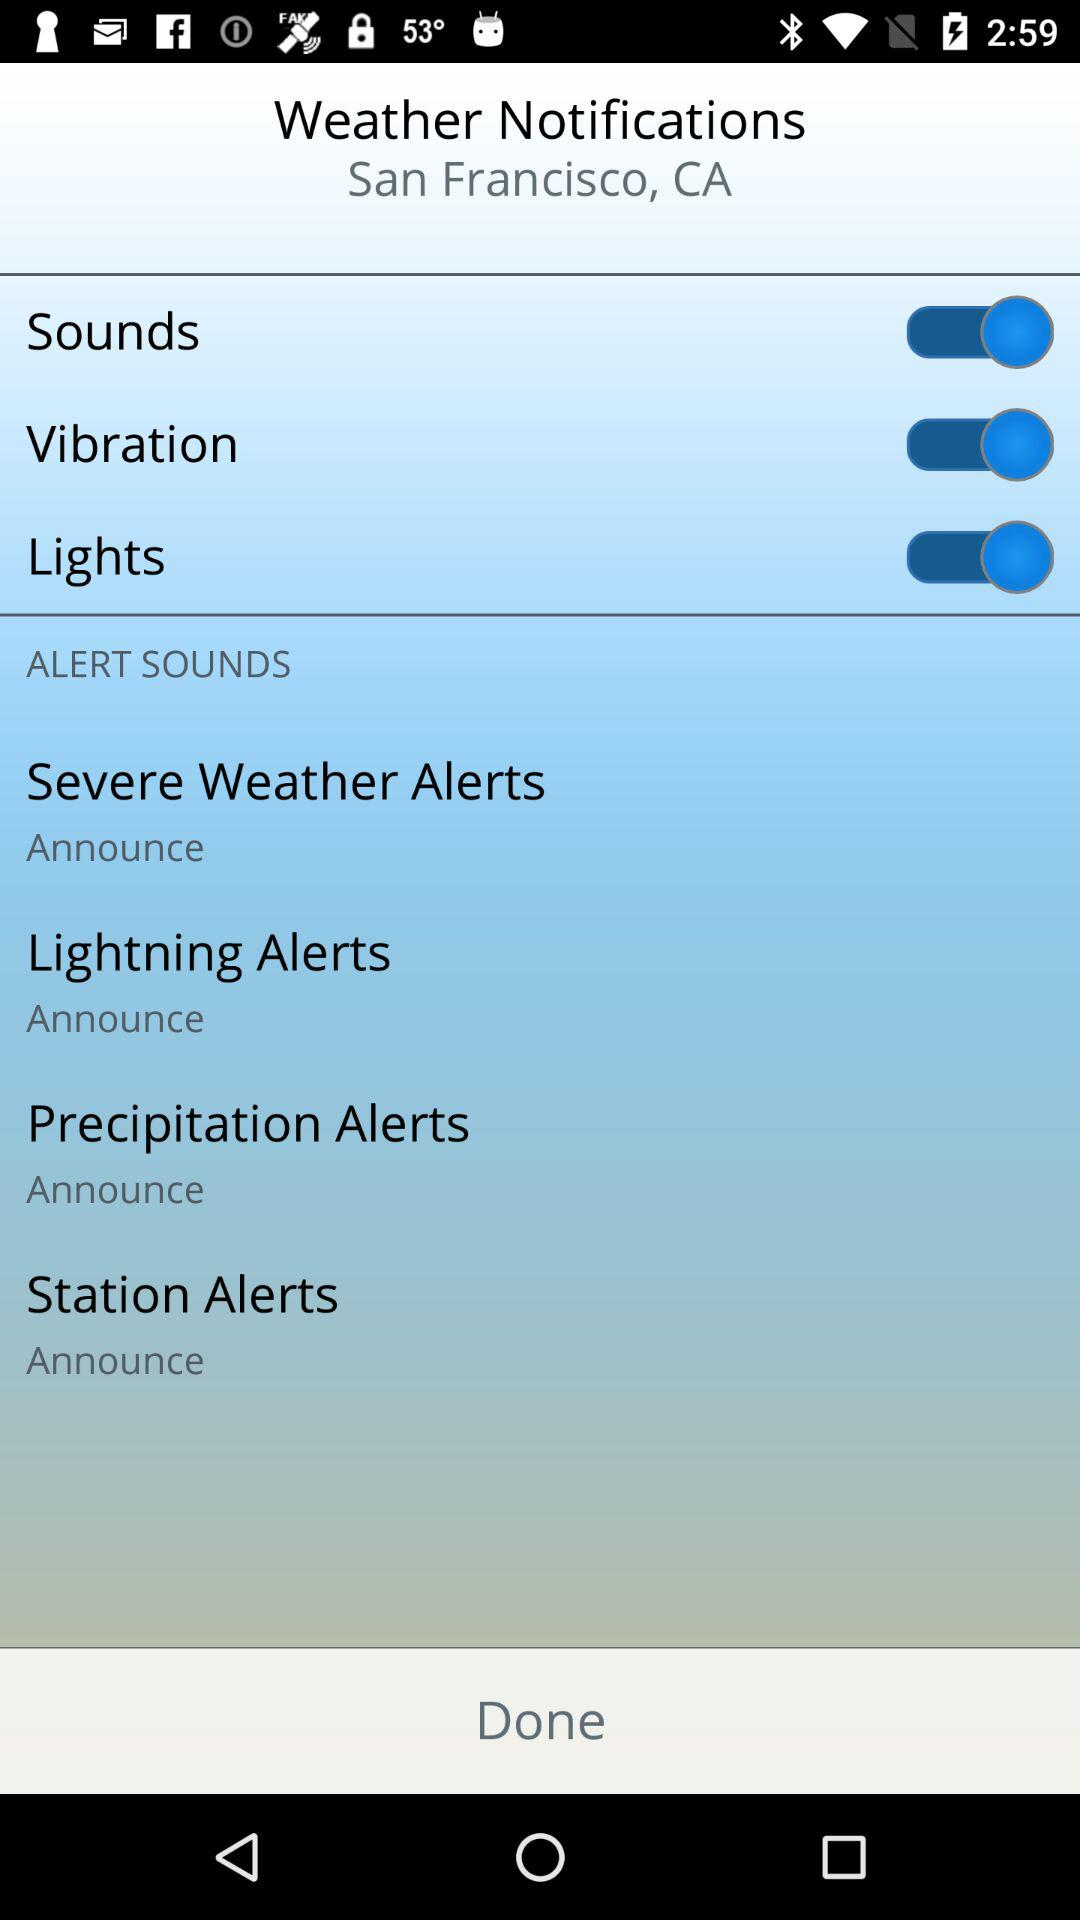What is the status of the "Lights"? The status of the "Lights" is "on". 